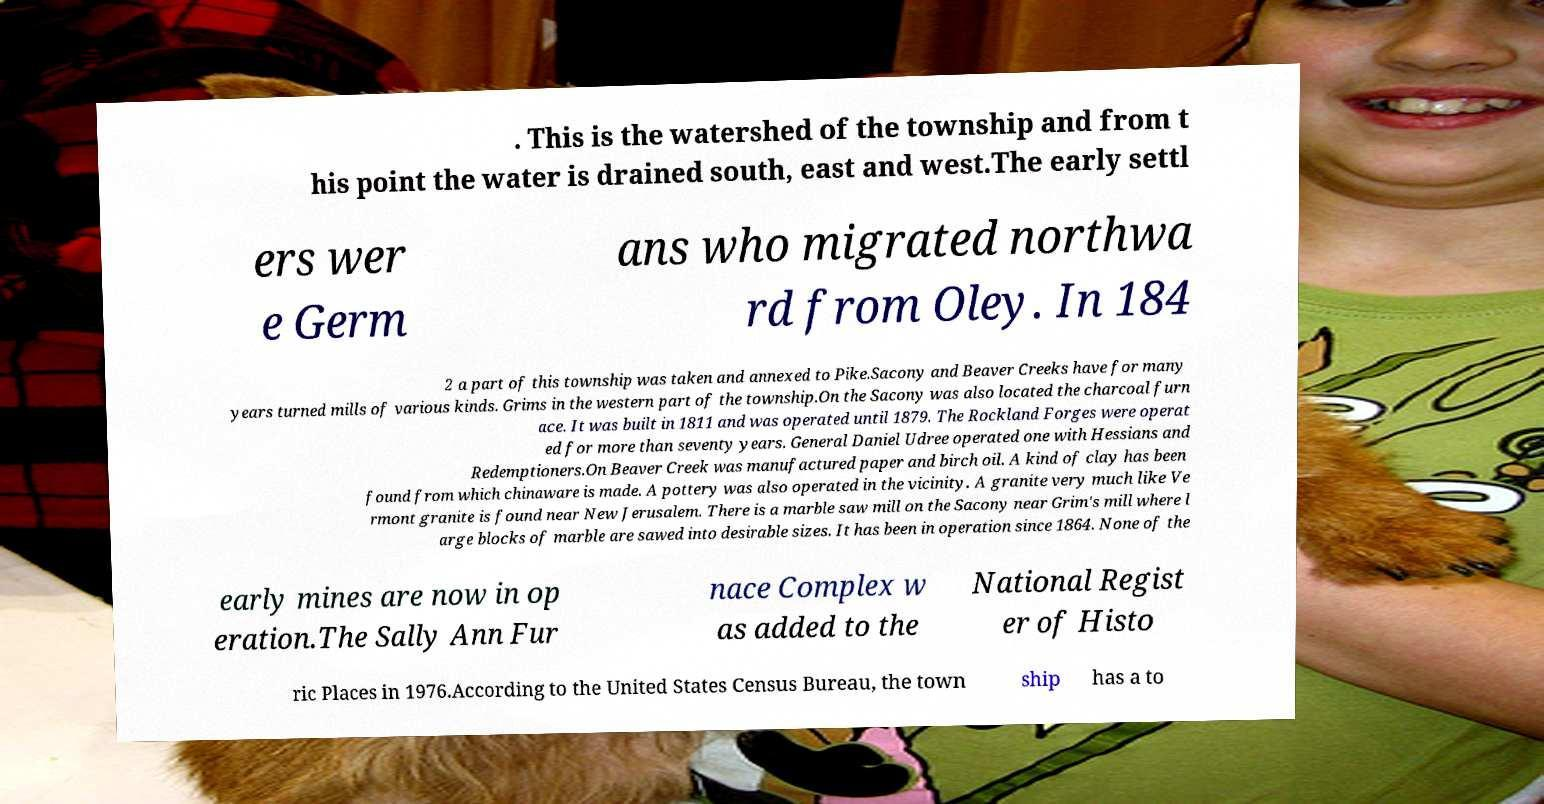Could you extract and type out the text from this image? . This is the watershed of the township and from t his point the water is drained south, east and west.The early settl ers wer e Germ ans who migrated northwa rd from Oley. In 184 2 a part of this township was taken and annexed to Pike.Sacony and Beaver Creeks have for many years turned mills of various kinds. Grims in the western part of the township.On the Sacony was also located the charcoal furn ace. It was built in 1811 and was operated until 1879. The Rockland Forges were operat ed for more than seventy years. General Daniel Udree operated one with Hessians and Redemptioners.On Beaver Creek was manufactured paper and birch oil. A kind of clay has been found from which chinaware is made. A pottery was also operated in the vicinity. A granite very much like Ve rmont granite is found near New Jerusalem. There is a marble saw mill on the Sacony near Grim's mill where l arge blocks of marble are sawed into desirable sizes. It has been in operation since 1864. None of the early mines are now in op eration.The Sally Ann Fur nace Complex w as added to the National Regist er of Histo ric Places in 1976.According to the United States Census Bureau, the town ship has a to 